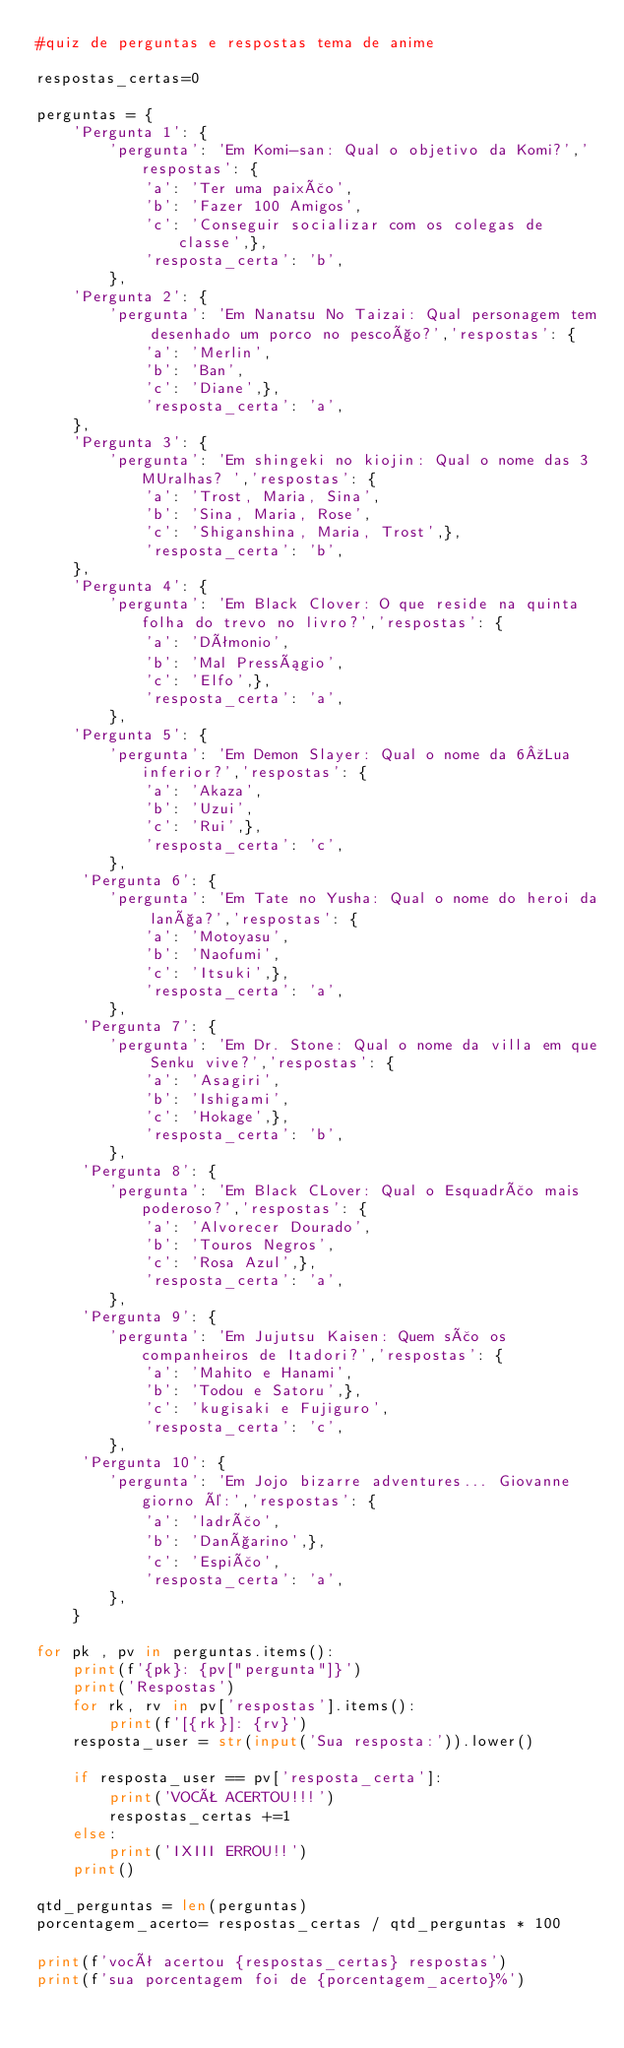Convert code to text. <code><loc_0><loc_0><loc_500><loc_500><_Python_>#quiz de perguntas e respostas tema de anime

respostas_certas=0

perguntas = {
    'Pergunta 1': {
        'pergunta': 'Em Komi-san: Qual o objetivo da Komi?','respostas': {
            'a': 'Ter uma paixão',
            'b': 'Fazer 100 Amigos',
            'c': 'Conseguir socializar com os colegas de classe',}, 
            'resposta_certa': 'b',
        },
    'Pergunta 2': {
        'pergunta': 'Em Nanatsu No Taizai: Qual personagem tem desenhado um porco no pescoço?','respostas': {
            'a': 'Merlin',
            'b': 'Ban',
            'c': 'Diane',}, 
            'resposta_certa': 'a',
    },
    'Pergunta 3': {
        'pergunta': 'Em shingeki no kiojin: Qual o nome das 3 MUralhas? ','respostas': {
            'a': 'Trost, Maria, Sina',
            'b': 'Sina, Maria, Rose',
            'c': 'Shiganshina, Maria, Trost',}, 
            'resposta_certa': 'b',
    },
    'Pergunta 4': {
        'pergunta': 'Em Black Clover: O que reside na quinta folha do trevo no livro?','respostas': {
            'a': 'Dêmonio',
            'b': 'Mal Presságio',
            'c': 'Elfo',}, 
            'resposta_certa': 'a',
        },
    'Pergunta 5': {
        'pergunta': 'Em Demon Slayer: Qual o nome da 6ºLua inferior?','respostas': {
            'a': 'Akaza',
            'b': 'Uzui',
            'c': 'Rui',}, 
            'resposta_certa': 'c',
        },
     'Pergunta 6': {
        'pergunta': 'Em Tate no Yusha: Qual o nome do heroi da lança?','respostas': {
            'a': 'Motoyasu',
            'b': 'Naofumi',
            'c': 'Itsuki',}, 
            'resposta_certa': 'a',
        },
     'Pergunta 7': {
        'pergunta': 'Em Dr. Stone: Qual o nome da villa em que Senku vive?','respostas': {
            'a': 'Asagiri',
            'b': 'Ishigami',
            'c': 'Hokage',}, 
            'resposta_certa': 'b',
        },
     'Pergunta 8': {
        'pergunta': 'Em Black CLover: Qual o Esquadrão mais poderoso?','respostas': {
            'a': 'Alvorecer Dourado',
            'b': 'Touros Negros',
            'c': 'Rosa Azul',}, 
            'resposta_certa': 'a',
        },
     'Pergunta 9': {
        'pergunta': 'Em Jujutsu Kaisen: Quem são os companheiros de Itadori?','respostas': {
            'a': 'Mahito e Hanami',
            'b': 'Todou e Satoru',}, 
            'c': 'kugisaki e Fujiguro',
            'resposta_certa': 'c',
        },
     'Pergunta 10': {
        'pergunta': 'Em Jojo bizarre adventures... Giovanne giorno é:','respostas': {
            'a': 'ladrão',
            'b': 'Dançarino',}, 
            'c': 'Espião',
            'resposta_certa': 'a',
        },
    }

for pk , pv in perguntas.items():
    print(f'{pk}: {pv["pergunta"]}')
    print('Respostas')
    for rk, rv in pv['respostas'].items():
        print(f'[{rk}]: {rv}')
    resposta_user = str(input('Sua resposta:')).lower()

    if resposta_user == pv['resposta_certa']:
        print('VOCÊ ACERTOU!!!')
        respostas_certas +=1
    else: 
        print('IXIII ERROU!!')
    print() 

qtd_perguntas = len(perguntas)
porcentagem_acerto= respostas_certas / qtd_perguntas * 100

print(f'você acertou {respostas_certas} respostas')
print(f'sua porcentagem foi de {porcentagem_acerto}%')</code> 